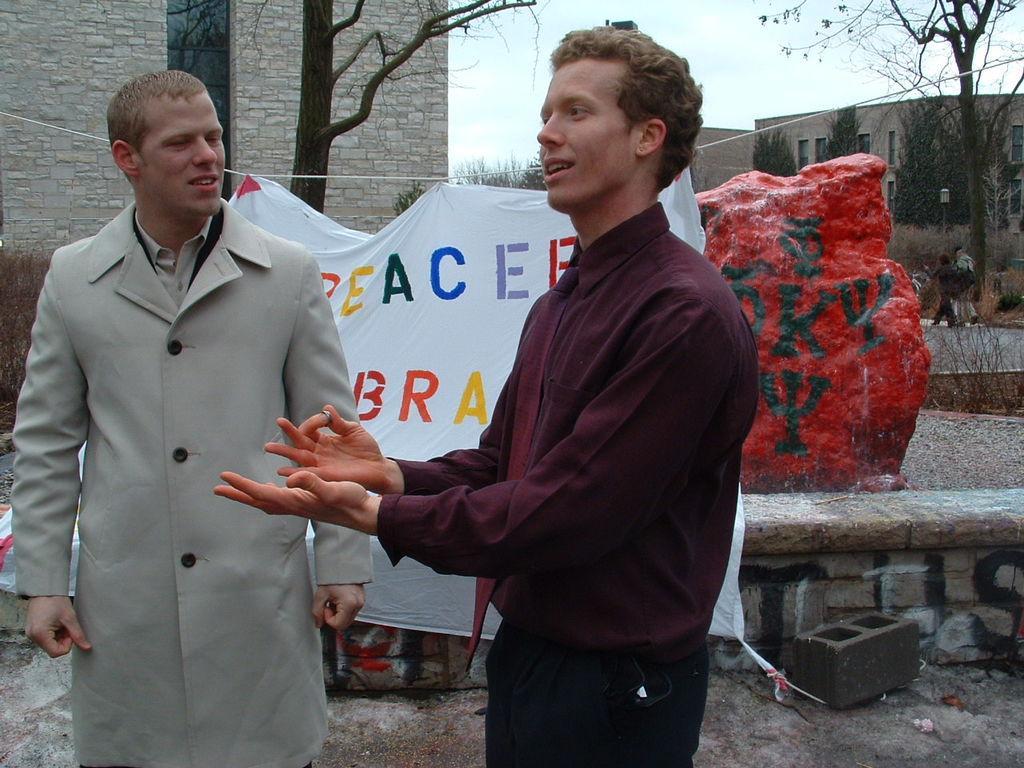How would you summarize this image in a sentence or two? In this picture there is a boy wearing red color shirt showing some hand sign. Beside there is a another boy wearing grey coat watching him. Behind there is a white banner. In the background we can see the brick wall and some dry trees. 